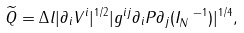Convert formula to latex. <formula><loc_0><loc_0><loc_500><loc_500>\widetilde { Q } = \Delta l | \partial _ { i } V ^ { i } | ^ { 1 / 2 } | g ^ { i j } \partial _ { i } P \partial _ { j } ( I _ { N } ^ { \ - 1 } ) | ^ { 1 / 4 } ,</formula> 